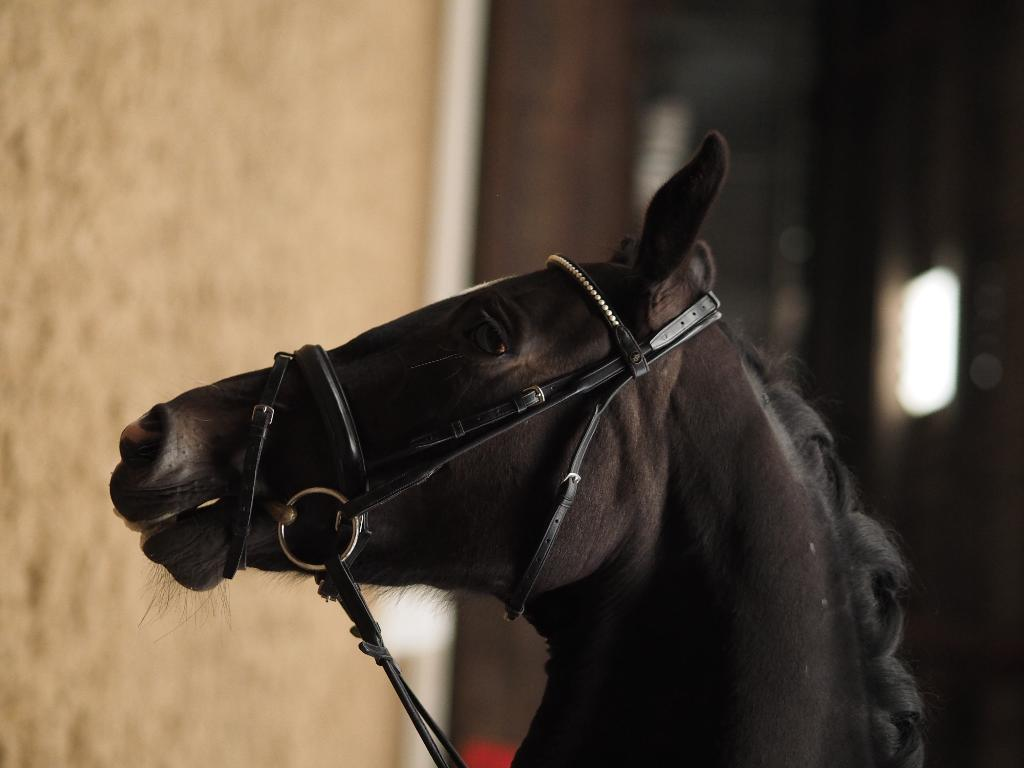What animal is present in the image? There is a horse in the image. Which part of the horse is visible? Only the head of the horse is visible. Can you describe the background of the image? The background of the horse is blurred. What time does the clock on the horse's chin show in the image? There is no clock present on the horse's chin in the image. 